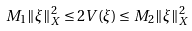Convert formula to latex. <formula><loc_0><loc_0><loc_500><loc_500>M _ { 1 } \| \xi \| _ { X } ^ { 2 } \leq 2 V ( \xi ) \leq M _ { 2 } \| \xi \| _ { X } ^ { 2 }</formula> 